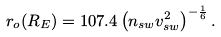Convert formula to latex. <formula><loc_0><loc_0><loc_500><loc_500>r _ { o } ( R _ { E } ) = 1 0 7 . 4 \left ( n _ { s w } v ^ { 2 } _ { s w } \right ) ^ { - \frac { 1 } { 6 } } .</formula> 